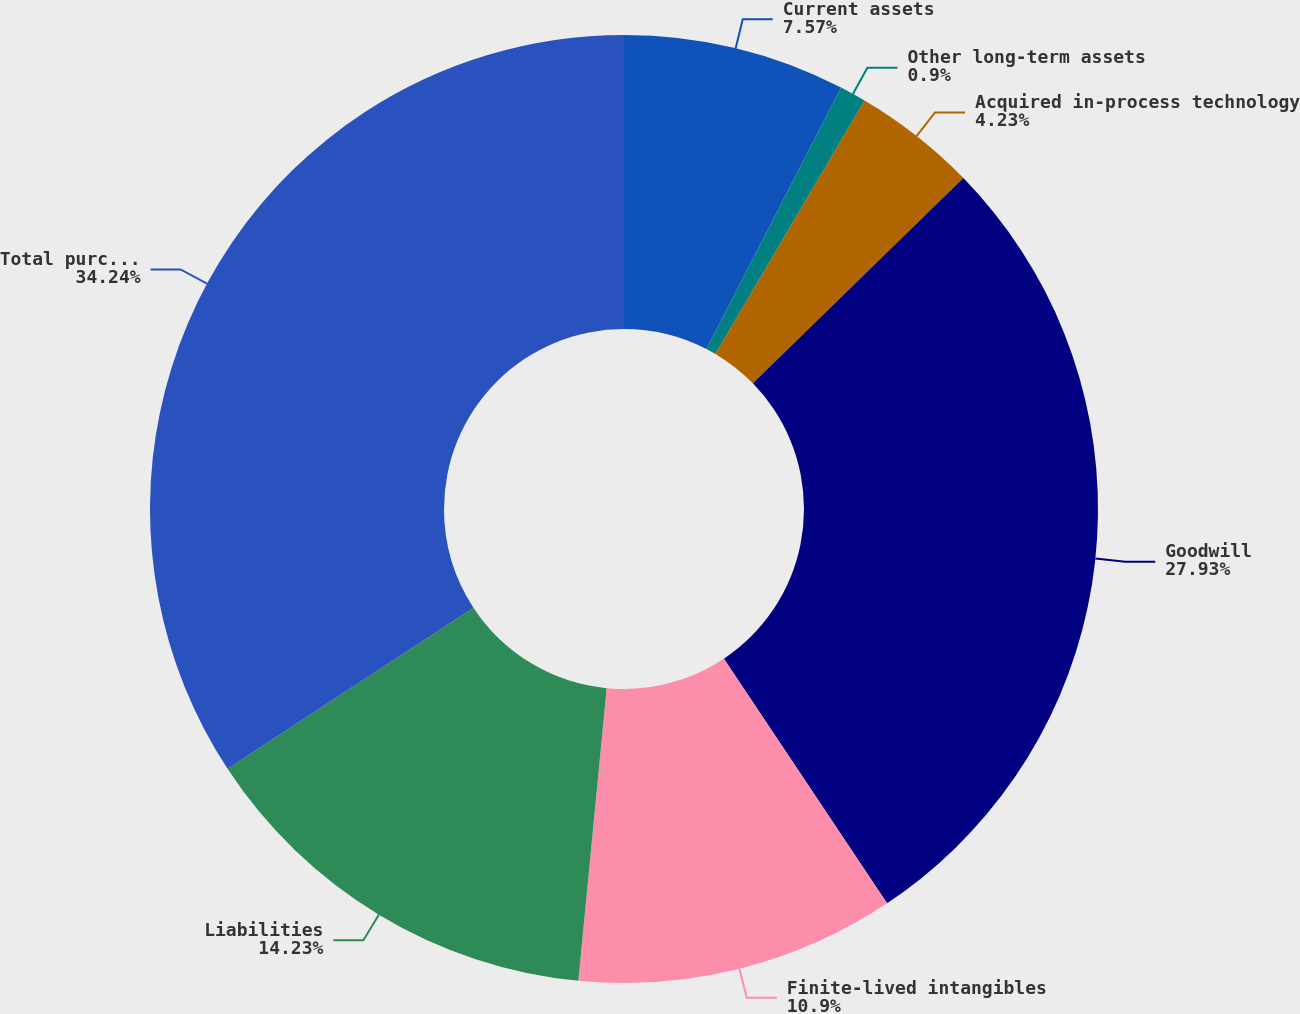<chart> <loc_0><loc_0><loc_500><loc_500><pie_chart><fcel>Current assets<fcel>Other long-term assets<fcel>Acquired in-process technology<fcel>Goodwill<fcel>Finite-lived intangibles<fcel>Liabilities<fcel>Total purchase price<nl><fcel>7.57%<fcel>0.9%<fcel>4.23%<fcel>27.93%<fcel>10.9%<fcel>14.23%<fcel>34.23%<nl></chart> 